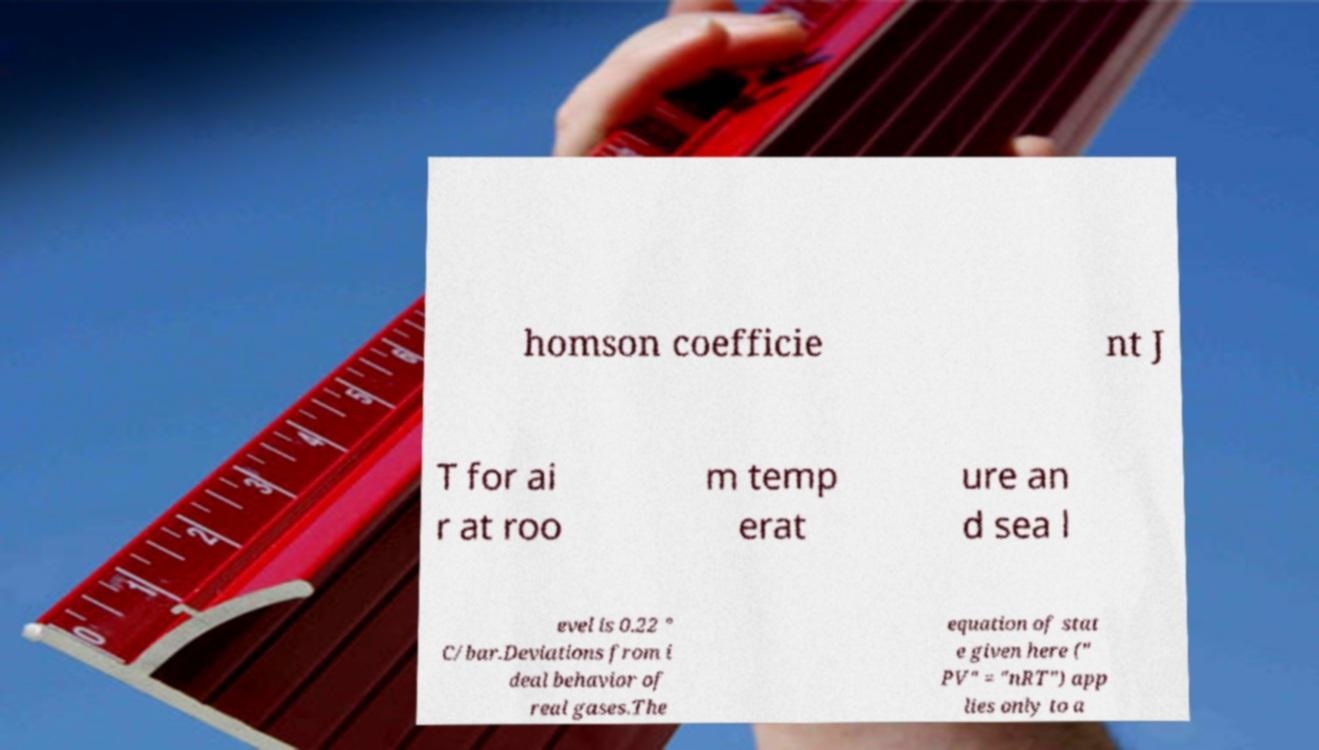Could you extract and type out the text from this image? homson coefficie nt J T for ai r at roo m temp erat ure an d sea l evel is 0.22 ° C/bar.Deviations from i deal behavior of real gases.The equation of stat e given here (" PV" = "nRT") app lies only to a 